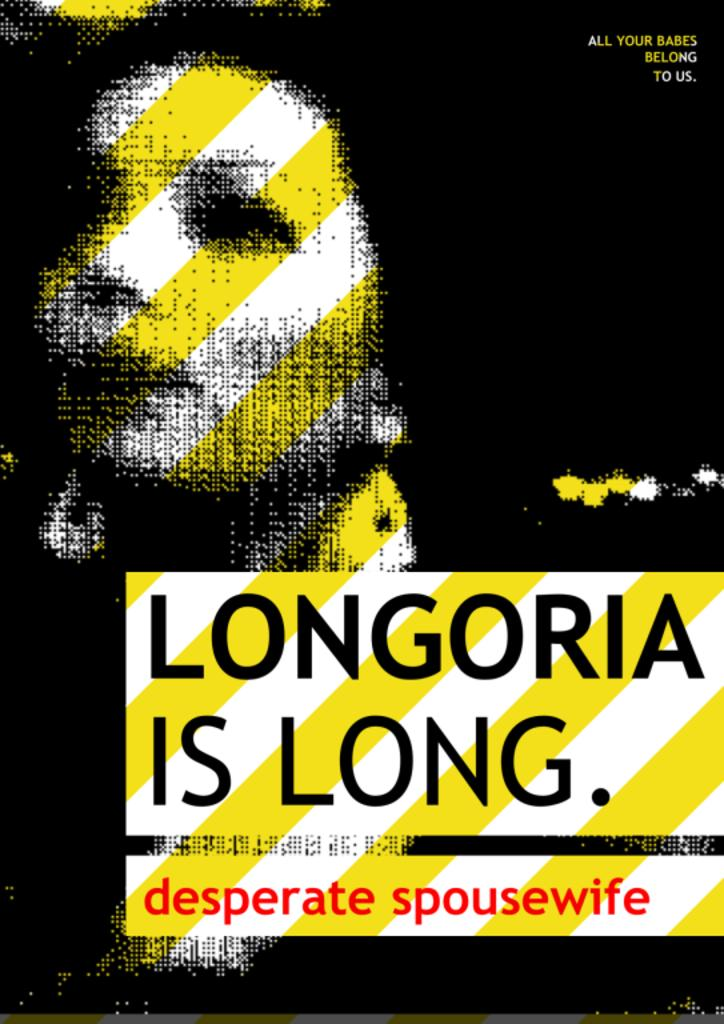<image>
Provide a brief description of the given image. A poster shows a woman and the text "Longoria Is Long". 